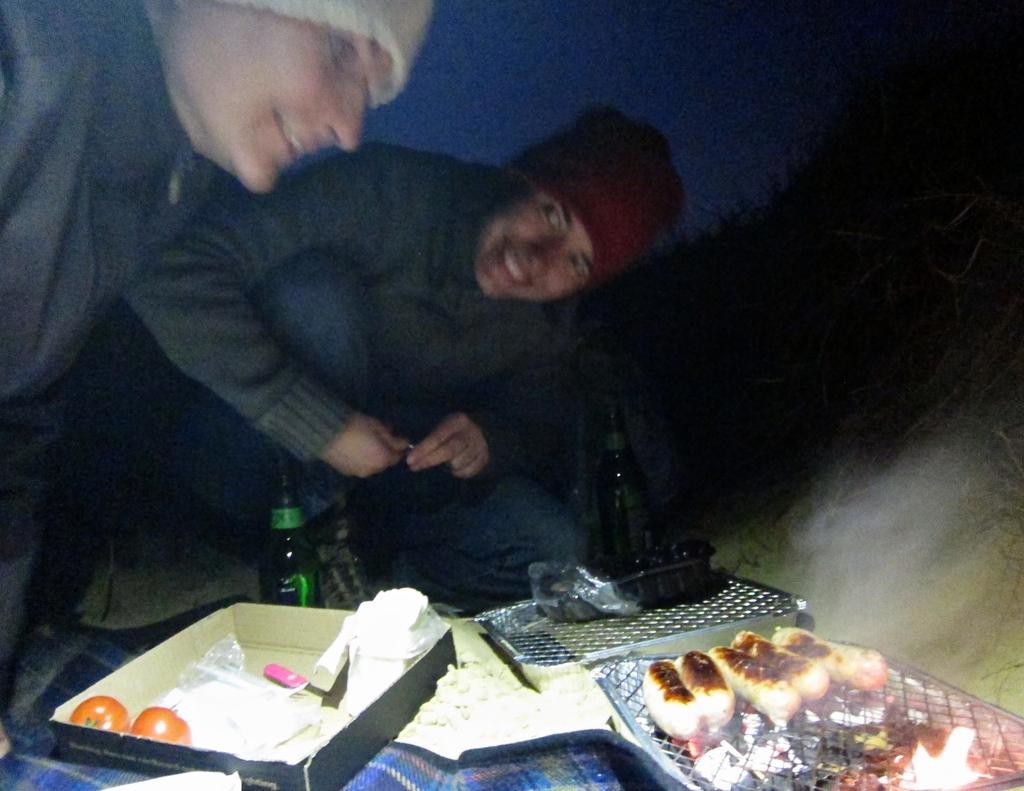Describe this image in one or two sentences. In this picture there are two persons who are sitting on the floor. Beside them I can see the cotton boxes, barbecue stand and other objects. In the bottom right corner I can see some rolls on the barbecue stand. In the top left I can see the sky. 